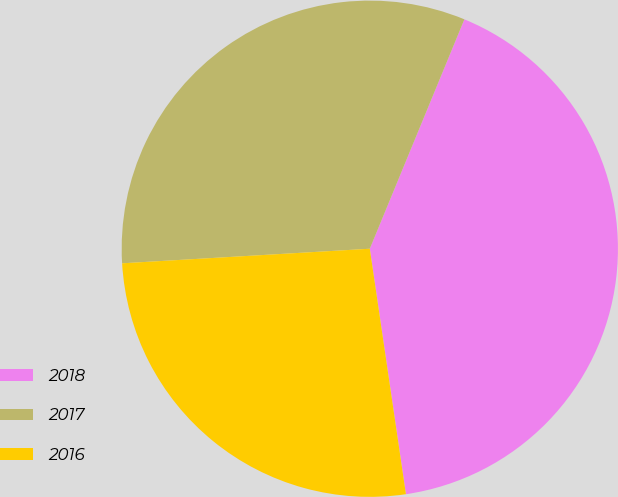Convert chart. <chart><loc_0><loc_0><loc_500><loc_500><pie_chart><fcel>2018<fcel>2017<fcel>2016<nl><fcel>41.45%<fcel>32.16%<fcel>26.39%<nl></chart> 